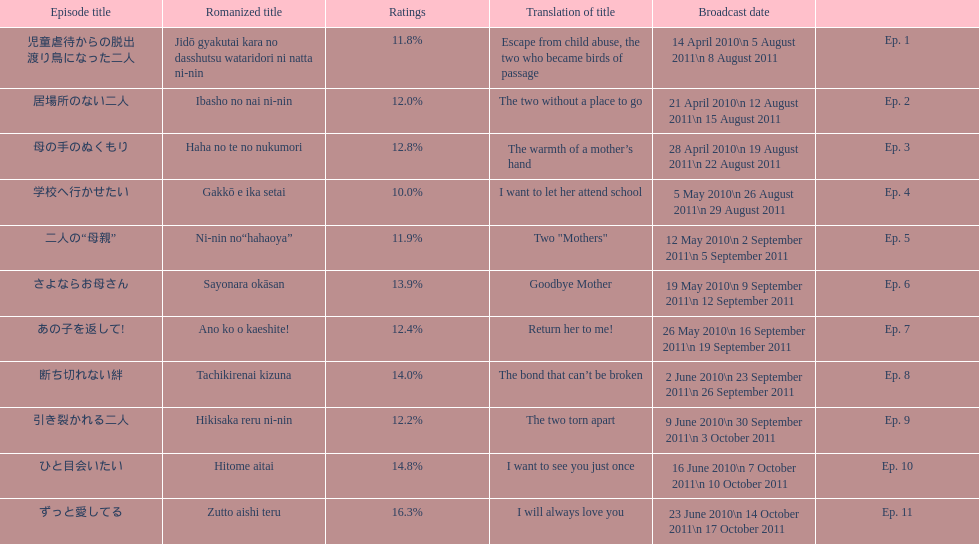Other than the 10th episode, which other episode has a 14% rating? Ep. 8. 